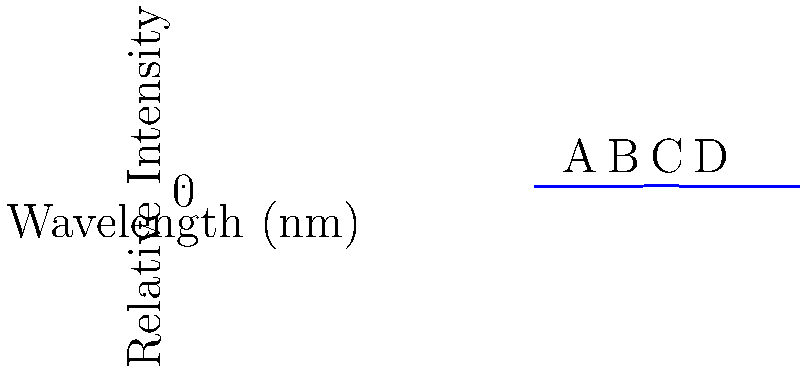As a researcher developing machine learning algorithms for biological data analysis, you're collaborating on a project to identify exoplanets with potential for harboring life. Given the spectral graph of a distant star's atmosphere, which element is most likely present based on the strongest absorption line labeled 'C' at approximately 550 nm? To determine the element present based on the strongest absorption line, we need to follow these steps:

1. Identify the wavelength of the strongest absorption line:
   The graph shows the strongest absorption (highest peak) at point C, which is at approximately 550 nm.

2. Recall common elemental absorption lines:
   Some common elemental absorption lines in stellar spectra include:
   - Hydrogen (H-alpha): 656.3 nm
   - Helium: 587.6 nm
   - Sodium (Na-D): 589.0 nm and 589.6 nm
   - Calcium (Ca II K): 393.4 nm
   - Magnesium: 518.4 nm

3. Compare the observed wavelength to known absorption lines:
   The closest match to our observed 550 nm line is the absorption line for sodium (Na-D) at 589.0 nm and 589.6 nm.

4. Consider potential factors affecting the observed wavelength:
   The slight difference between the observed 550 nm and the known 589 nm for sodium could be due to:
   - Redshift or blueshift caused by the star's motion relative to Earth
   - Instrumental errors or limitations in spectral resolution
   - Presence of other elements or compounds affecting the spectrum

5. Conclude based on the closest match:
   Given the information provided and the closest match to known elemental absorption lines, the element most likely present is sodium (Na).

It's important to note that in real-world scenarios, more precise measurements and additional spectral lines would be necessary for a definitive identification. Machine learning algorithms could be trained to recognize patterns in these spectra for more accurate element identification.
Answer: Sodium (Na) 